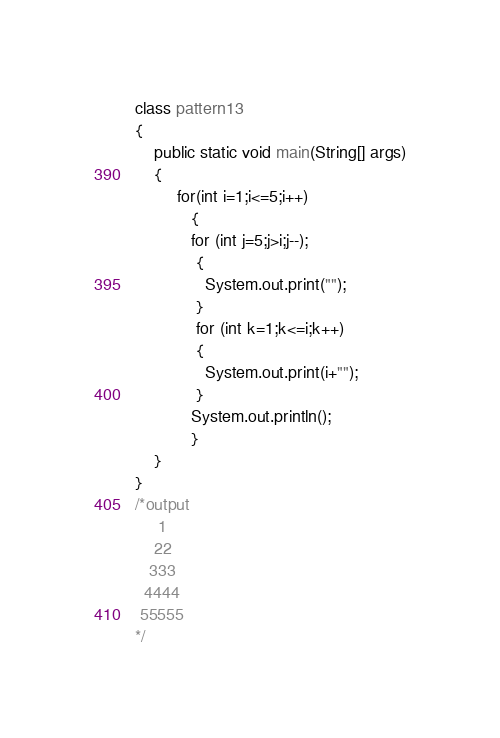Convert code to text. <code><loc_0><loc_0><loc_500><loc_500><_Java_>class pattern13
{
    public static void main(String[] args)
    {
         for(int i=1;i<=5;i++)
            {
            for (int j=5;j>i;j--);
             {
               System.out.print("");
			 }
			 for (int k=1;k<=i;k++)
             { 
               System.out.print(i+"");
			 }
            System.out.println();
            }
    }
}
/*output
     1
	22
   333 
  4444
 55555 
*/</code> 